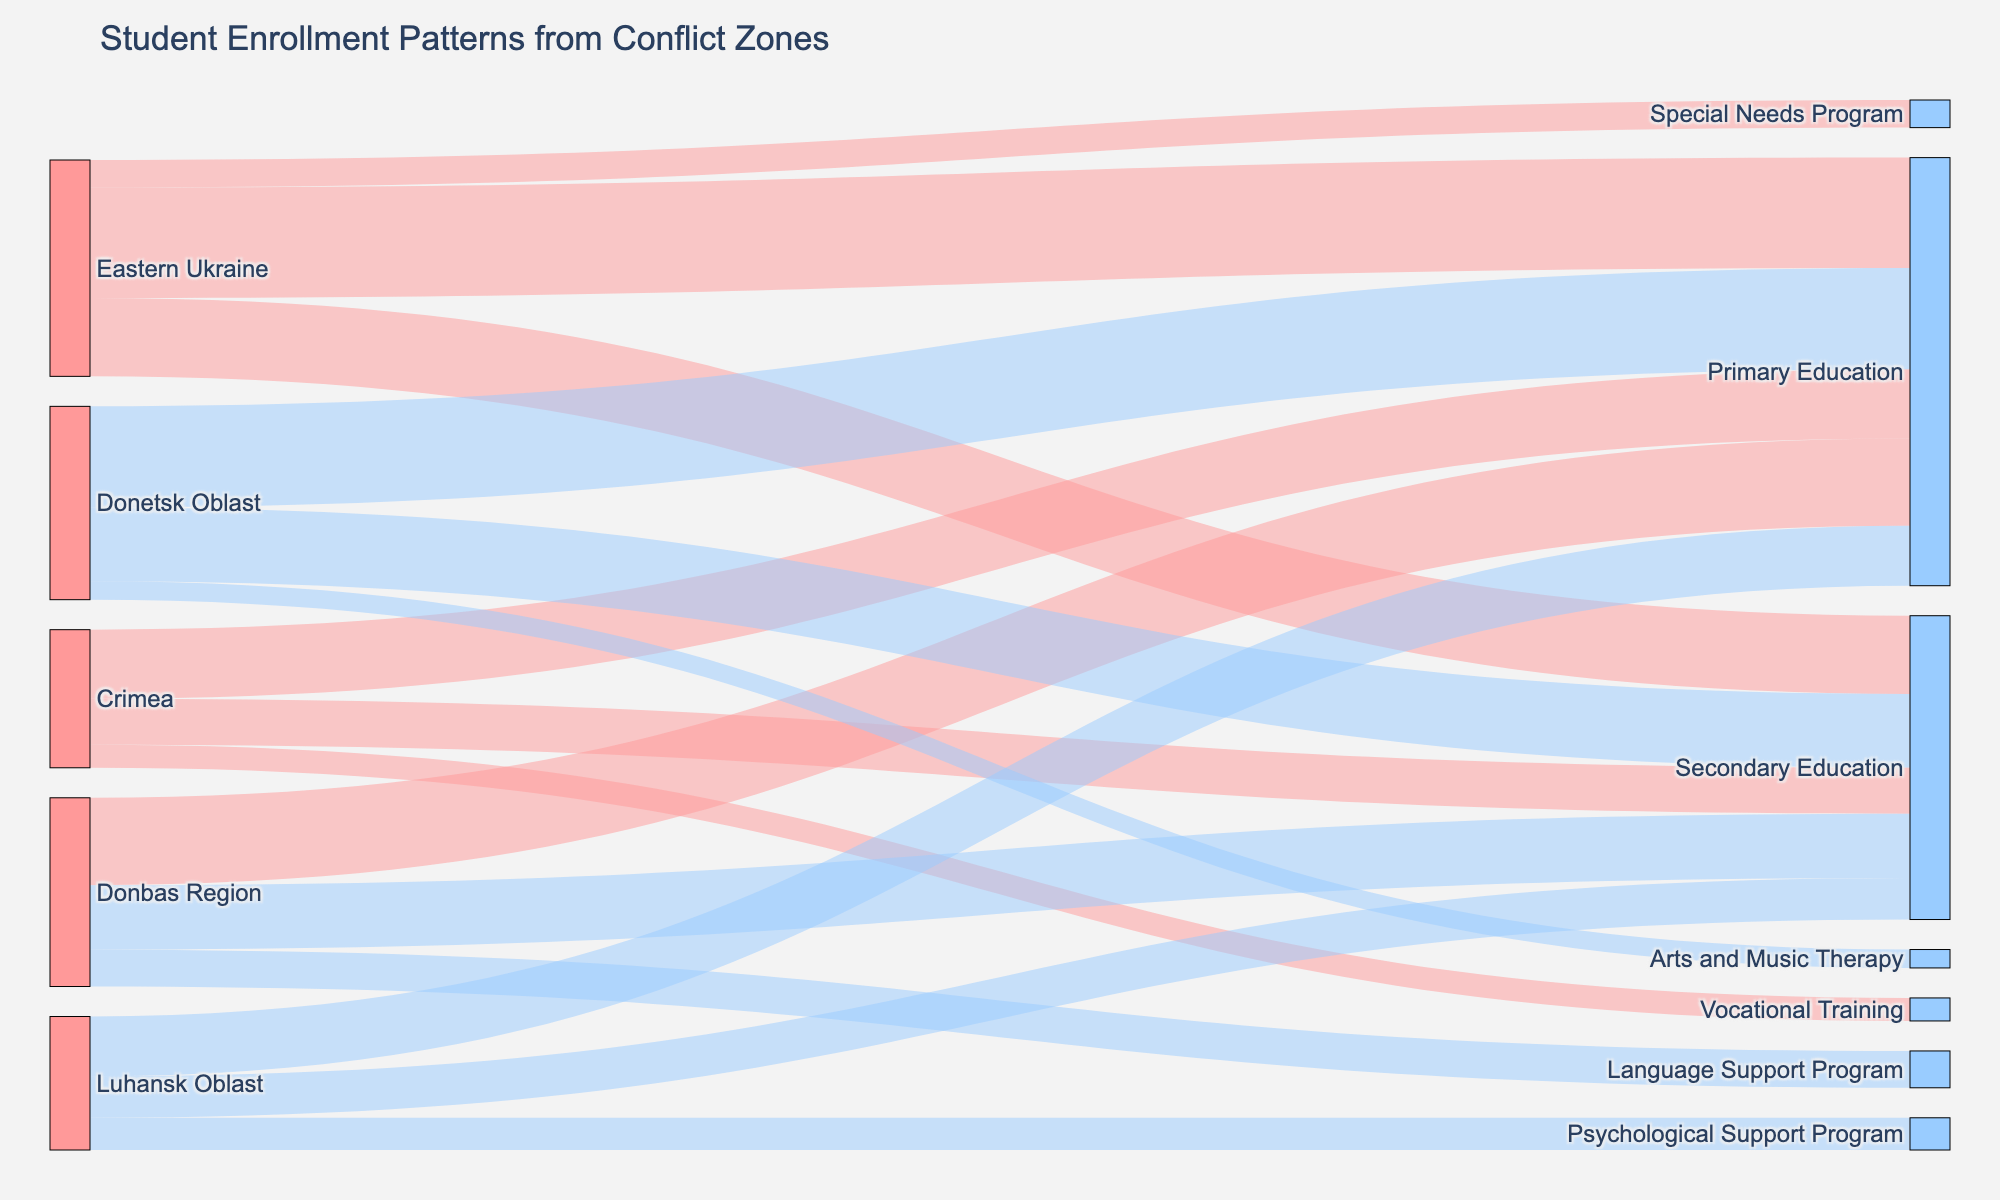What sources are included in the Sankey diagram? The Sankey diagram includes the following sources: Eastern Ukraine, Crimea, Donbas Region, Luhansk Oblast, and Donetsk Oblast. This can be seen on the left-hand side of the Sankey diagram where the source nodes are listed.
Answer: Eastern Ukraine, Crimea, Donbas Region, Luhansk Oblast, Donetsk Oblast What is the title of the Sankey diagram? The title of the Sankey diagram is displayed at the top of the figure.
Answer: Student Enrollment Patterns from Conflict Zones Which educational program receives the highest number of enrollments from Eastern Ukraine? To determine this, look at the links originating from Eastern Ukraine and identify which target (educational program) has the highest value. The links show enrollments of 120 to Primary Education, 85 to Secondary Education, and 30 to Special Needs Program.
Answer: Primary Education How many total enrollments are there for Primary Education across all conflict zones? Sum the values of the links leading to Primary Education from each conflict zone: 120 (Eastern Ukraine) + 75 (Crimea) + 95 (Donbas Region) + 65 (Luhansk Oblast) + 110 (Donetsk Oblast). This gives 120 + 75 + 95 + 65 + 110 = 465.
Answer: 465 Compare the enrollments for Secondary Education between Donetsk Oblast and Donbas Region. Which one has higher enrollments? Look at the links leading to Secondary Education from Donetsk Oblast (80) and Donbas Region (70). Since 80 > 70, Donetsk Oblast has higher enrollments in Secondary Education.
Answer: Donetsk Oblast What is the total number of enrollments from Crimea? Sum the values of all the links originating from Crimea. These are 75 (Primary Education) + 50 (Secondary Education) + 25 (Vocational Training), resulting in a total of 75 + 50 + 25 = 150.
Answer: 150 What proportion of students from Luhansk Oblast are enrolled in the Psychological Support Program? First, find the total number of enrollments from Luhansk Oblast: 65 (Primary Education) + 45 (Secondary Education) + 35 (Psychological Support Program) = 145. Then, calculate the proportion for the Psychological Support Program: 35 / 145 ≈ 0.241 or 24.1%.
Answer: 24.1% Which conflict zone has the least number of students in Secondary Education? Check the links leading to Secondary Education: Eastern Ukraine (85), Crimea (50), Donbas Region (70), Luhansk Oblast (45), Donetsk Oblast (80). Crimea has the least number of enrollments with 50 students.
Answer: Crimea Identify the conflict zone that contributes the most students to Vocational Training. Since only Crimea has students enrolled in Vocational Training, with 25 students, it is the conflict zone contributing the most.
Answer: Crimea 